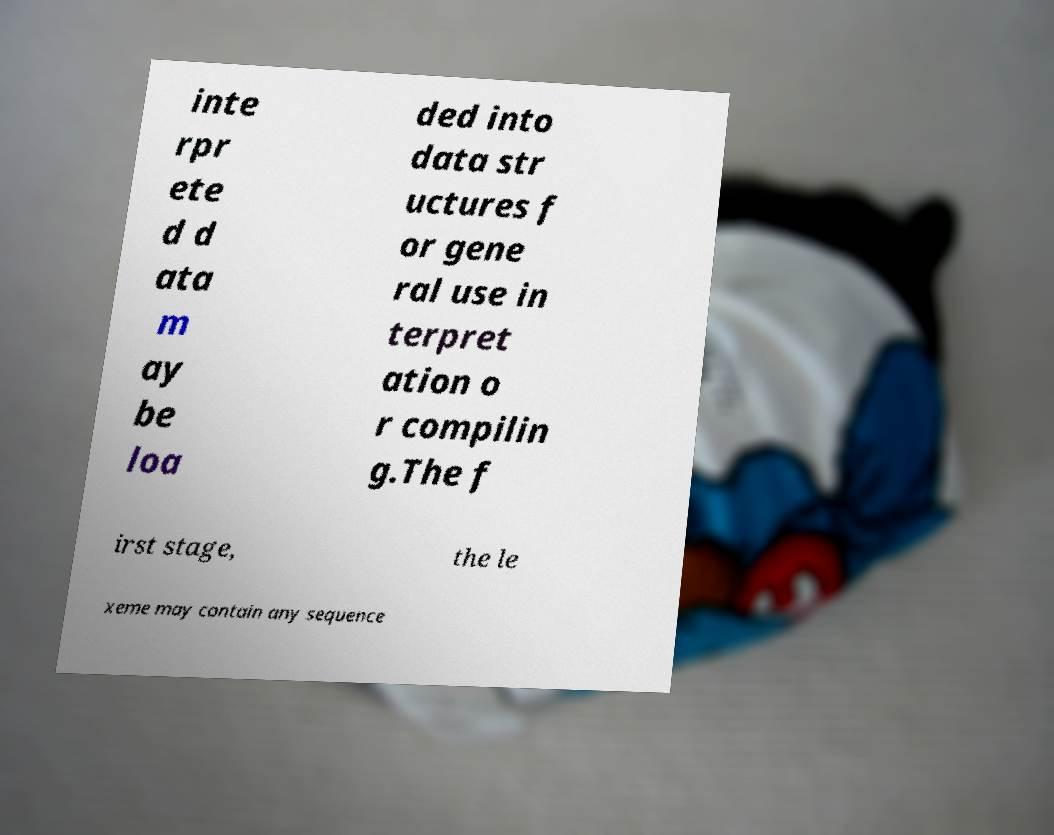Please read and relay the text visible in this image. What does it say? inte rpr ete d d ata m ay be loa ded into data str uctures f or gene ral use in terpret ation o r compilin g.The f irst stage, the le xeme may contain any sequence 